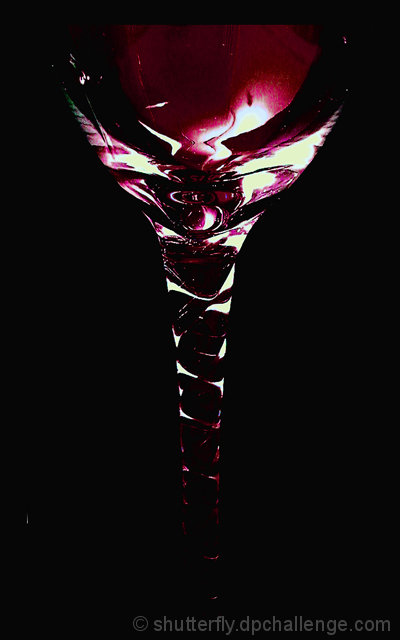Would you say this image is an example of professional photography? The image appears to be professionally taken, with a strong focus on composition, lighting, and subject highlighting which are all hallmarks of a skilled photographer. 